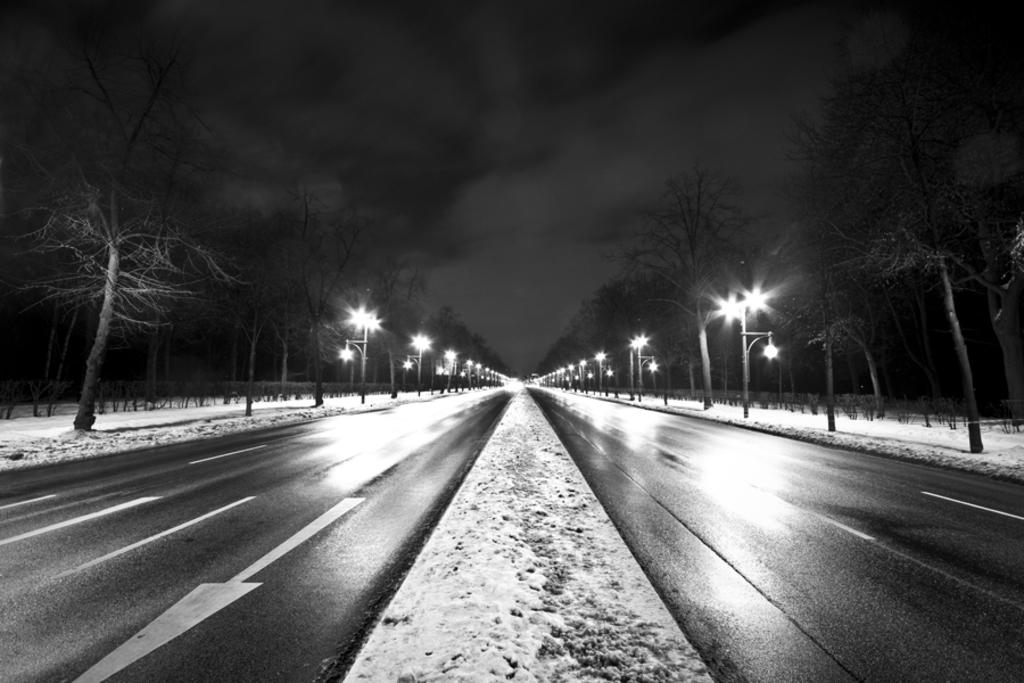What can be seen on the roads in the image? The roads in the image are empty. What structures are present alongside the roads? There are light poles in the image. What type of vegetation is visible in the image? There are trees in the image. What type of punishment is being administered to the trees in the image? There is no punishment being administered to the trees in the image; they are simply standing there. 